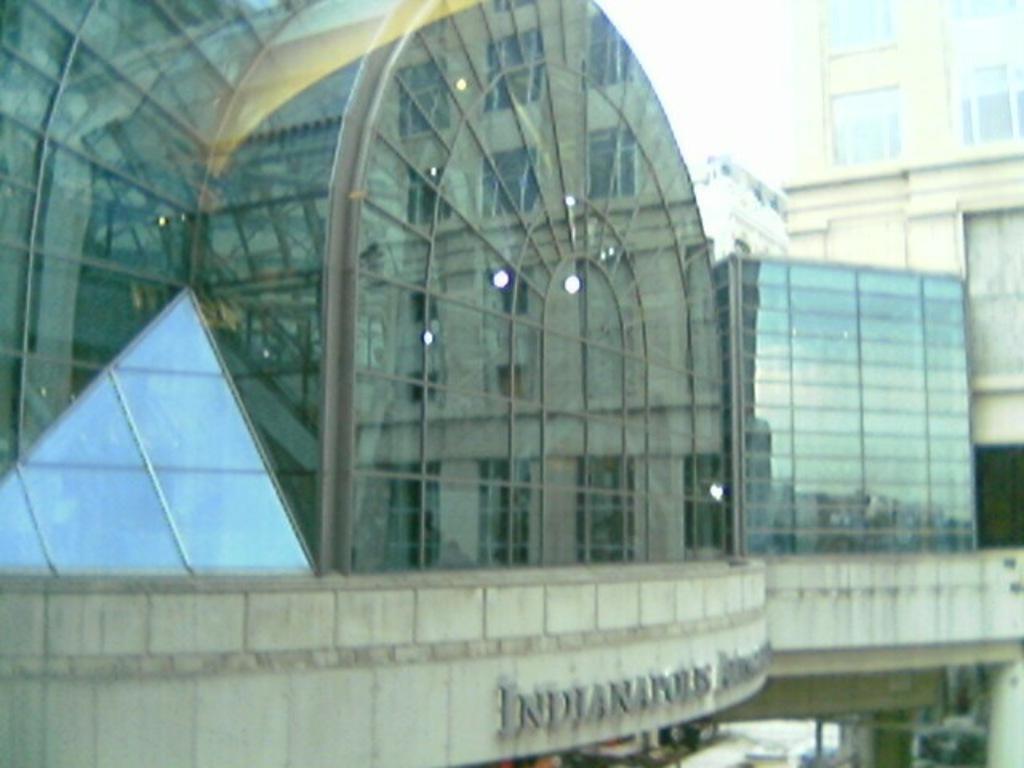In one or two sentences, can you explain what this image depicts? In this image we can see buildings and sky. 